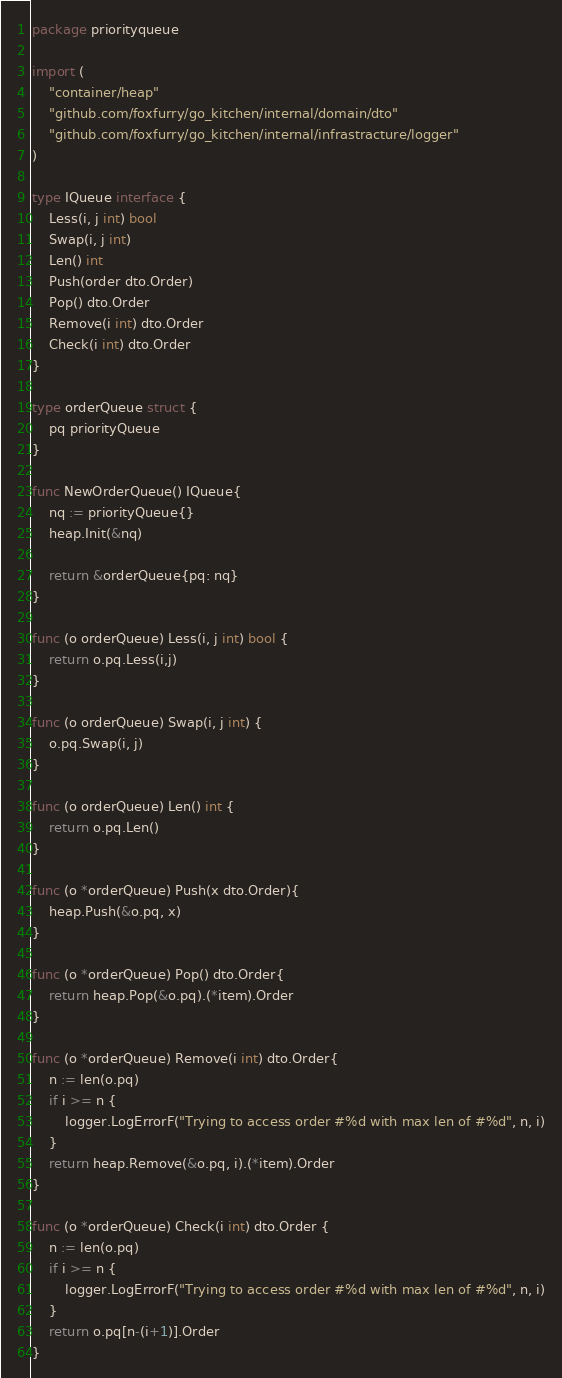<code> <loc_0><loc_0><loc_500><loc_500><_Go_>package priorityqueue

import (
	"container/heap"
	"github.com/foxfurry/go_kitchen/internal/domain/dto"
	"github.com/foxfurry/go_kitchen/internal/infrastracture/logger"
)

type IQueue interface {
	Less(i, j int) bool
	Swap(i, j int)
	Len() int
	Push(order dto.Order)
	Pop() dto.Order
	Remove(i int) dto.Order
	Check(i int) dto.Order
}

type orderQueue struct {
	pq priorityQueue
}

func NewOrderQueue() IQueue{
	nq := priorityQueue{}
	heap.Init(&nq)

	return &orderQueue{pq: nq}
}

func (o orderQueue) Less(i, j int) bool {
	return o.pq.Less(i,j)
}

func (o orderQueue) Swap(i, j int) {
	o.pq.Swap(i, j)
}

func (o orderQueue) Len() int {
	return o.pq.Len()
}

func (o *orderQueue) Push(x dto.Order){
	heap.Push(&o.pq, x)
}

func (o *orderQueue) Pop() dto.Order{
	return heap.Pop(&o.pq).(*item).Order
}

func (o *orderQueue) Remove(i int) dto.Order{
	n := len(o.pq)
	if i >= n {
		logger.LogErrorF("Trying to access order #%d with max len of #%d", n, i)
	}
	return heap.Remove(&o.pq, i).(*item).Order
}

func (o *orderQueue) Check(i int) dto.Order {
	n := len(o.pq)
	if i >= n {
		logger.LogErrorF("Trying to access order #%d with max len of #%d", n, i)
	}
	return o.pq[n-(i+1)].Order
}</code> 